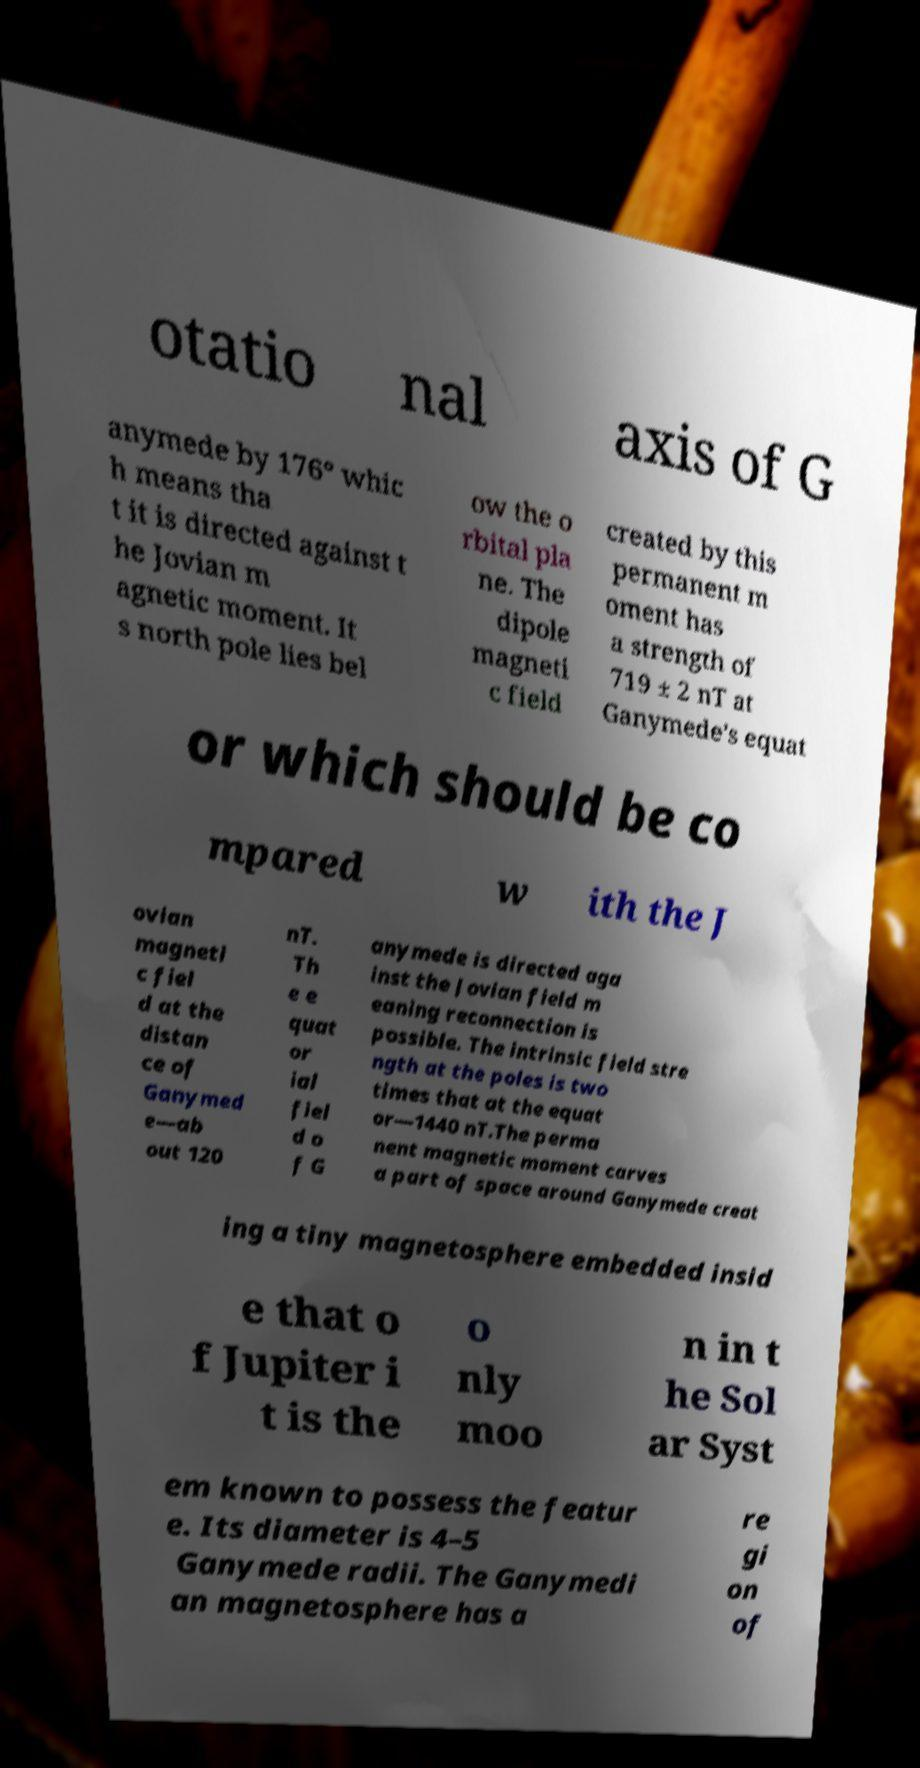I need the written content from this picture converted into text. Can you do that? otatio nal axis of G anymede by 176° whic h means tha t it is directed against t he Jovian m agnetic moment. It s north pole lies bel ow the o rbital pla ne. The dipole magneti c field created by this permanent m oment has a strength of 719 ± 2 nT at Ganymede's equat or which should be co mpared w ith the J ovian magneti c fiel d at the distan ce of Ganymed e—ab out 120 nT. Th e e quat or ial fiel d o f G anymede is directed aga inst the Jovian field m eaning reconnection is possible. The intrinsic field stre ngth at the poles is two times that at the equat or—1440 nT.The perma nent magnetic moment carves a part of space around Ganymede creat ing a tiny magnetosphere embedded insid e that o f Jupiter i t is the o nly moo n in t he Sol ar Syst em known to possess the featur e. Its diameter is 4–5 Ganymede radii. The Ganymedi an magnetosphere has a re gi on of 